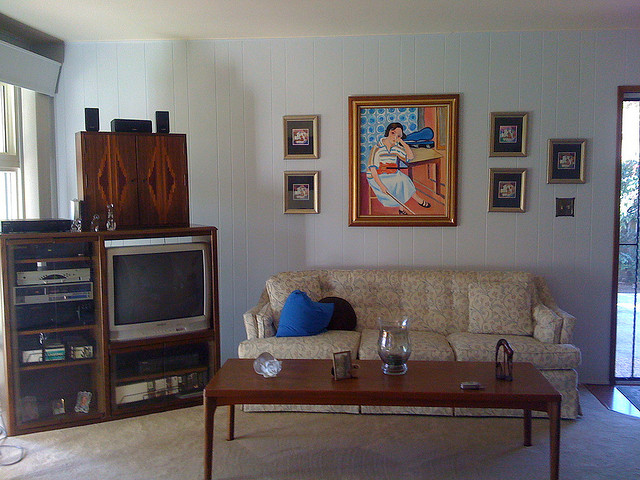<image>Why is the coffee table empty? I don't know why the coffee table is empty. It is also possible that it isn't empty. What color is the after picture? There is no after picture in the image. Why is the coffee table empty? I don't know why the coffee table is empty. It can be because it was cleaned or someone cleaned it. What color is the after picture? It is unclear what color is the after picture. It could be brown, blue, red and blue, or multicolored. 